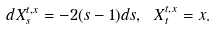Convert formula to latex. <formula><loc_0><loc_0><loc_500><loc_500>d X ^ { t , x } _ { s } = - 2 ( s - 1 ) d s , \ X ^ { t , x } _ { t } = x .</formula> 